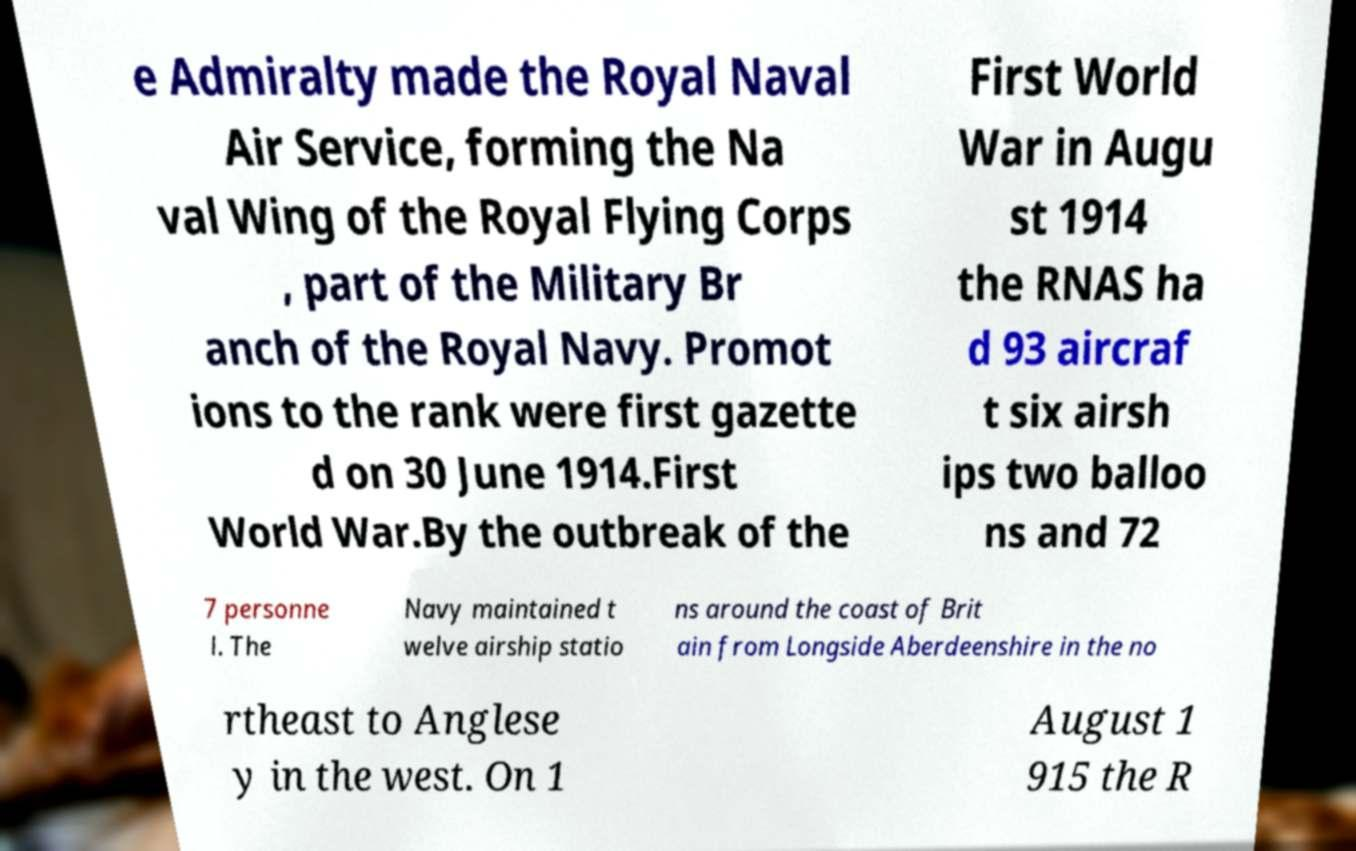There's text embedded in this image that I need extracted. Can you transcribe it verbatim? e Admiralty made the Royal Naval Air Service, forming the Na val Wing of the Royal Flying Corps , part of the Military Br anch of the Royal Navy. Promot ions to the rank were first gazette d on 30 June 1914.First World War.By the outbreak of the First World War in Augu st 1914 the RNAS ha d 93 aircraf t six airsh ips two balloo ns and 72 7 personne l. The Navy maintained t welve airship statio ns around the coast of Brit ain from Longside Aberdeenshire in the no rtheast to Anglese y in the west. On 1 August 1 915 the R 